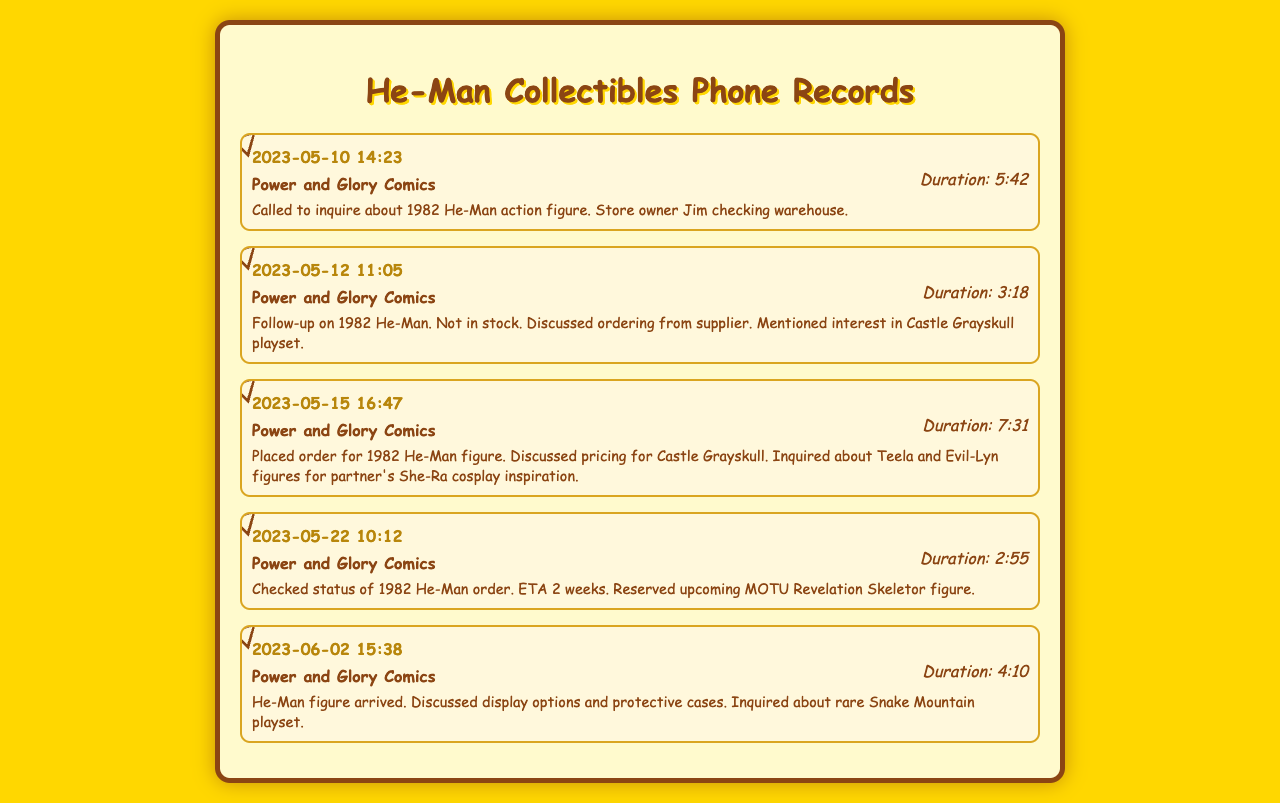What is the date of the first phone call? The first phone call recorded in the document is on May 10, 2023.
Answer: May 10, 2023 Who is the store owner mentioned in the calls? The store owner who is mentioned during the calls is Jim.
Answer: Jim What item was ordered on May 15, 2023? On May 15, 2023, the order placed was for the 1982 He-Man figure.
Answer: 1982 He-Man figure How long was the call on June 2, 2023? The duration of the call on June 2, 2023, was 4 minutes and 10 seconds.
Answer: 4:10 What was the estimated delivery time for the 1982 He-Man order? The estimated delivery time for the 1982 He-Man order was 2 weeks.
Answer: 2 weeks What collectible was discussed in the call on May 12, 2023? The collectible discussed in the call on May 12, 2023, was the Castle Grayskull playset.
Answer: Castle Grayskull playset Which figures were inquired about to inspire She-Ra cosplay? The figures inquired about for She-Ra cosplay inspiration were Teela and Evil-Lyn.
Answer: Teela and Evil-Lyn What is the name of the comic book store in the records? The name of the comic book store is Power and Glory Comics.
Answer: Power and Glory Comics What collectible was reserved during the call on May 22, 2023? The collectible reserved during the call on May 22, 2023, was the upcoming MOTU Revelation Skeletor figure.
Answer: MOTU Revelation Skeletor figure 